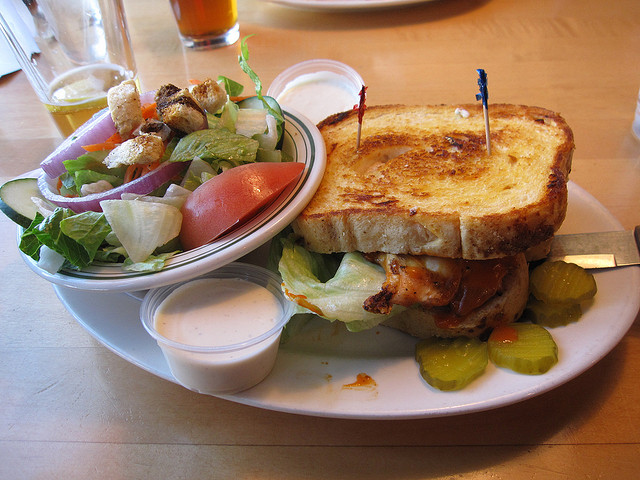What brand of beer is on the table? The image does not explicitly show a beer brand, making it difficult to ascertain which brand is on the table. 